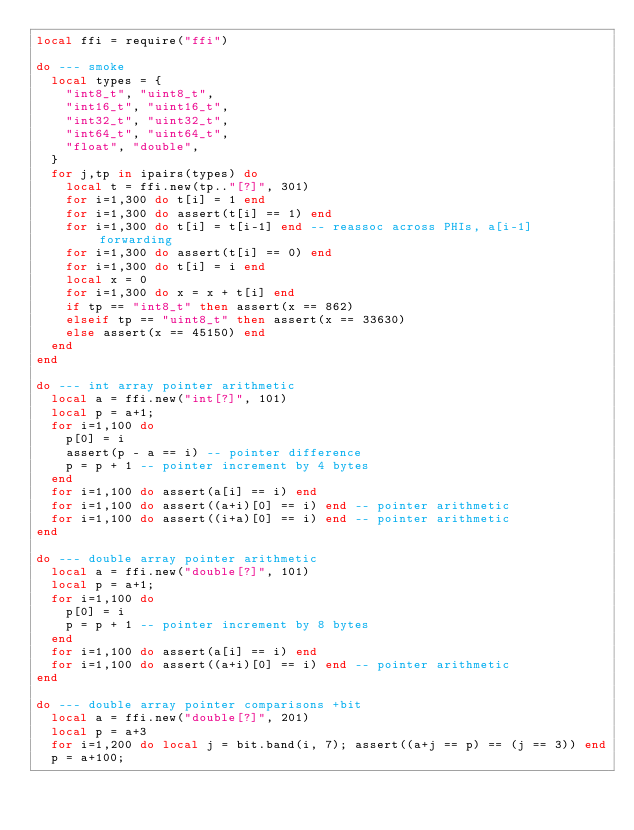Convert code to text. <code><loc_0><loc_0><loc_500><loc_500><_Lua_>local ffi = require("ffi")

do --- smoke
  local types = {
    "int8_t", "uint8_t",
    "int16_t", "uint16_t",
    "int32_t", "uint32_t",
    "int64_t", "uint64_t",
    "float", "double",
  }
  for j,tp in ipairs(types) do
    local t = ffi.new(tp.."[?]", 301)
    for i=1,300 do t[i] = 1 end
    for i=1,300 do assert(t[i] == 1) end
    for i=1,300 do t[i] = t[i-1] end -- reassoc across PHIs, a[i-1] forwarding
    for i=1,300 do assert(t[i] == 0) end
    for i=1,300 do t[i] = i end
    local x = 0
    for i=1,300 do x = x + t[i] end
    if tp == "int8_t" then assert(x == 862)
    elseif tp == "uint8_t" then assert(x == 33630)
    else assert(x == 45150) end
  end
end

do --- int array pointer arithmetic
  local a = ffi.new("int[?]", 101)
  local p = a+1;
  for i=1,100 do
    p[0] = i
    assert(p - a == i) -- pointer difference
    p = p + 1 -- pointer increment by 4 bytes
  end
  for i=1,100 do assert(a[i] == i) end
  for i=1,100 do assert((a+i)[0] == i) end -- pointer arithmetic
  for i=1,100 do assert((i+a)[0] == i) end -- pointer arithmetic
end

do --- double array pointer arithmetic
  local a = ffi.new("double[?]", 101)
  local p = a+1;
  for i=1,100 do
    p[0] = i
    p = p + 1 -- pointer increment by 8 bytes
  end
  for i=1,100 do assert(a[i] == i) end
  for i=1,100 do assert((a+i)[0] == i) end -- pointer arithmetic
end

do --- double array pointer comparisons +bit
  local a = ffi.new("double[?]", 201)
  local p = a+3
  for i=1,200 do local j = bit.band(i, 7); assert((a+j == p) == (j == 3)) end
  p = a+100;</code> 